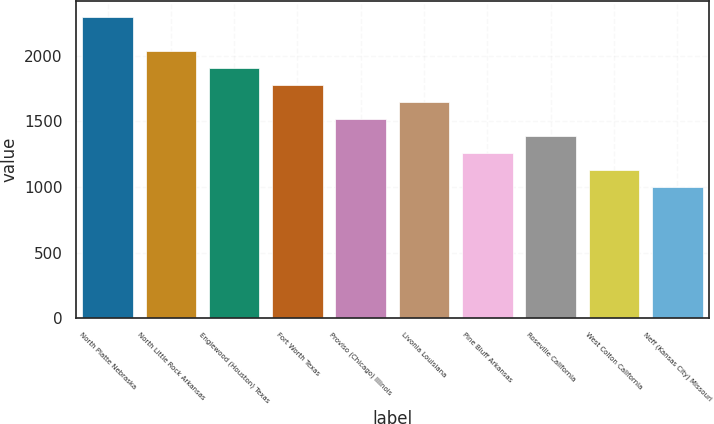Convert chart. <chart><loc_0><loc_0><loc_500><loc_500><bar_chart><fcel>North Platte Nebraska<fcel>North Little Rock Arkansas<fcel>Englewood (Houston) Texas<fcel>Fort Worth Texas<fcel>Proviso (Chicago) Illinois<fcel>Livonia Louisiana<fcel>Pine Bluff Arkansas<fcel>Roseville California<fcel>West Colton California<fcel>Neff (Kansas City) Missouri<nl><fcel>2300<fcel>2040<fcel>1910<fcel>1780<fcel>1520<fcel>1650<fcel>1260<fcel>1390<fcel>1130<fcel>1000<nl></chart> 